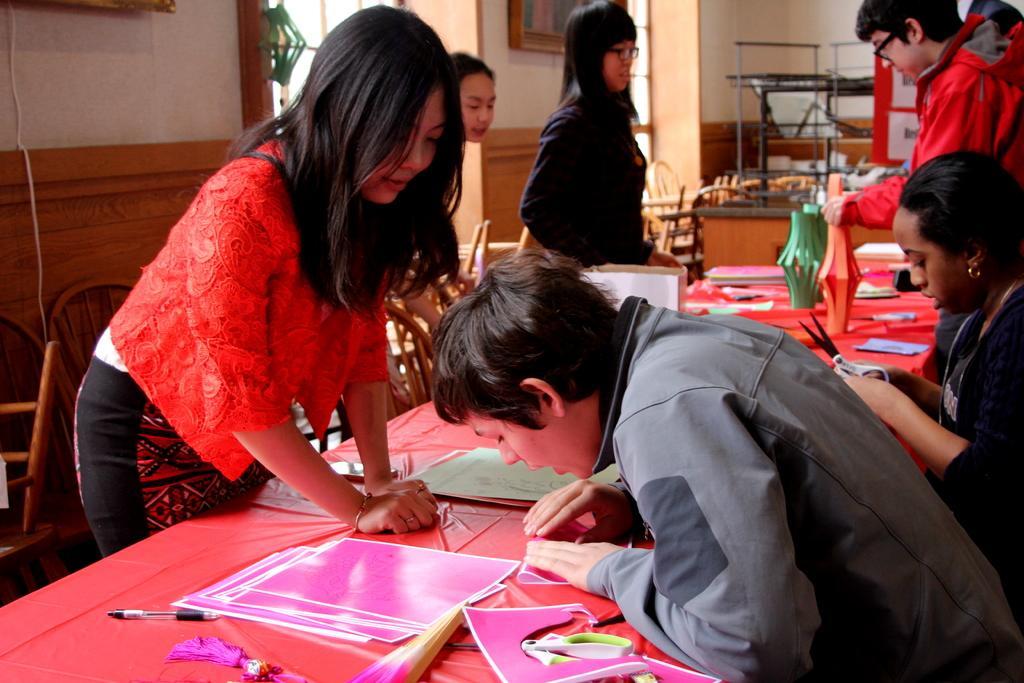How would you summarize this image in a sentence or two? In this picture we can see a few people and chairs. We can see a pen and some colorful objects on the table. There is a woman holding a scissor in her hand. We can see some objects and the frames on the wall. 